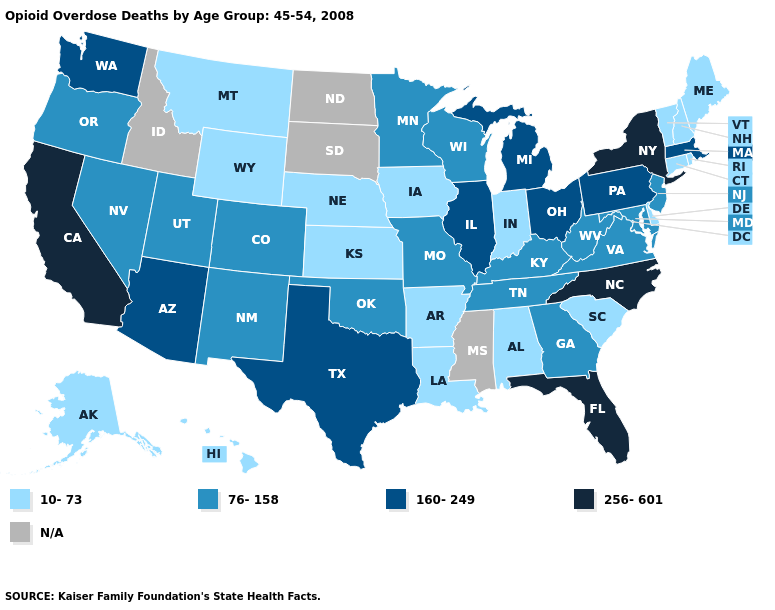Which states have the highest value in the USA?
Keep it brief. California, Florida, New York, North Carolina. What is the value of Ohio?
Short answer required. 160-249. What is the lowest value in states that border New Jersey?
Short answer required. 10-73. Which states have the lowest value in the USA?
Be succinct. Alabama, Alaska, Arkansas, Connecticut, Delaware, Hawaii, Indiana, Iowa, Kansas, Louisiana, Maine, Montana, Nebraska, New Hampshire, Rhode Island, South Carolina, Vermont, Wyoming. Which states have the highest value in the USA?
Short answer required. California, Florida, New York, North Carolina. Among the states that border New Mexico , does Arizona have the highest value?
Quick response, please. Yes. What is the lowest value in the USA?
Write a very short answer. 10-73. Does Indiana have the lowest value in the USA?
Be succinct. Yes. What is the value of Arkansas?
Concise answer only. 10-73. Which states have the lowest value in the USA?
Quick response, please. Alabama, Alaska, Arkansas, Connecticut, Delaware, Hawaii, Indiana, Iowa, Kansas, Louisiana, Maine, Montana, Nebraska, New Hampshire, Rhode Island, South Carolina, Vermont, Wyoming. What is the highest value in states that border Mississippi?
Give a very brief answer. 76-158. Name the states that have a value in the range 76-158?
Answer briefly. Colorado, Georgia, Kentucky, Maryland, Minnesota, Missouri, Nevada, New Jersey, New Mexico, Oklahoma, Oregon, Tennessee, Utah, Virginia, West Virginia, Wisconsin. What is the lowest value in states that border Alabama?
Answer briefly. 76-158. 